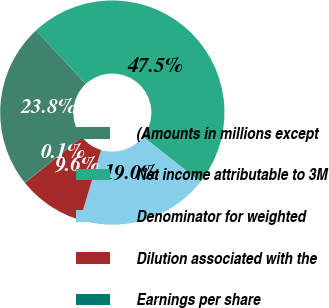Convert chart to OTSL. <chart><loc_0><loc_0><loc_500><loc_500><pie_chart><fcel>(Amounts in millions except<fcel>Net income attributable to 3M<fcel>Denominator for weighted<fcel>Dilution associated with the<fcel>Earnings per share<nl><fcel>23.8%<fcel>47.53%<fcel>19.05%<fcel>9.56%<fcel>0.07%<nl></chart> 